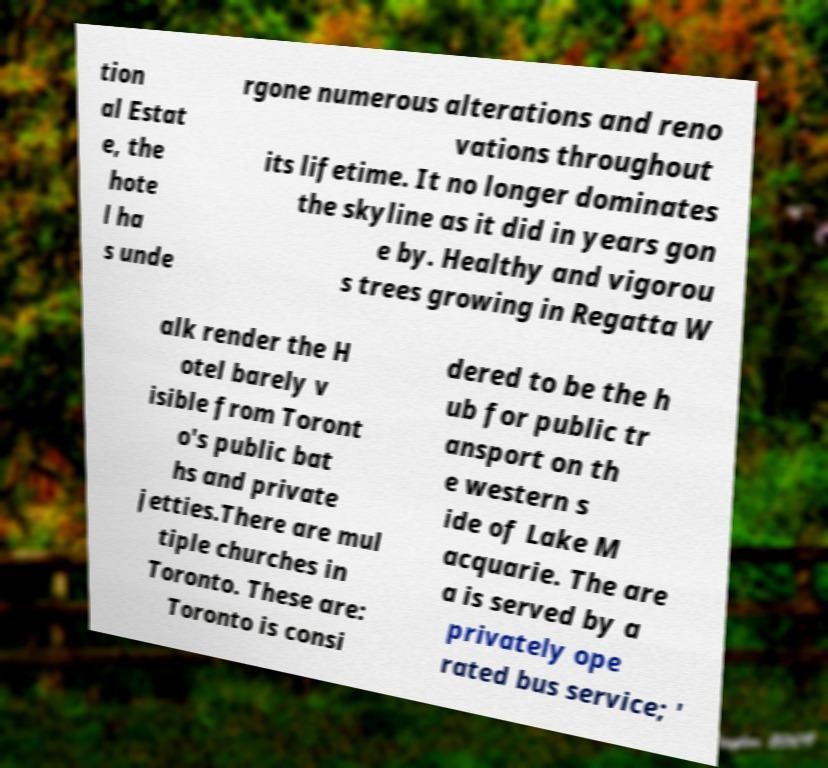I need the written content from this picture converted into text. Can you do that? tion al Estat e, the hote l ha s unde rgone numerous alterations and reno vations throughout its lifetime. It no longer dominates the skyline as it did in years gon e by. Healthy and vigorou s trees growing in Regatta W alk render the H otel barely v isible from Toront o's public bat hs and private jetties.There are mul tiple churches in Toronto. These are: Toronto is consi dered to be the h ub for public tr ansport on th e western s ide of Lake M acquarie. The are a is served by a privately ope rated bus service; ' 